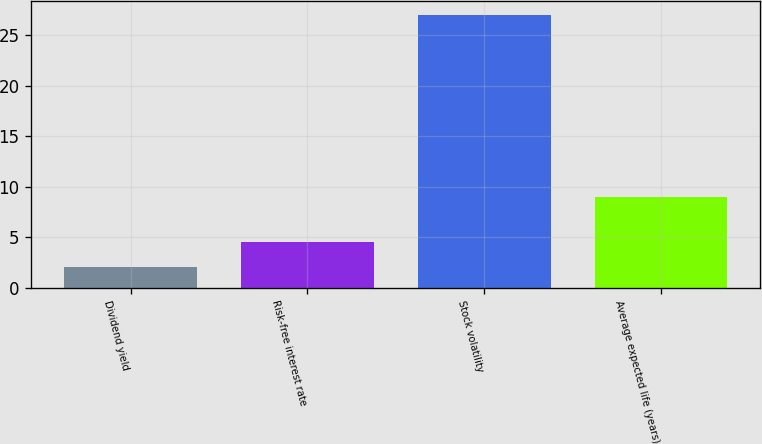Convert chart to OTSL. <chart><loc_0><loc_0><loc_500><loc_500><bar_chart><fcel>Dividend yield<fcel>Risk-free interest rate<fcel>Stock volatility<fcel>Average expected life (years)<nl><fcel>2<fcel>4.5<fcel>27<fcel>9<nl></chart> 